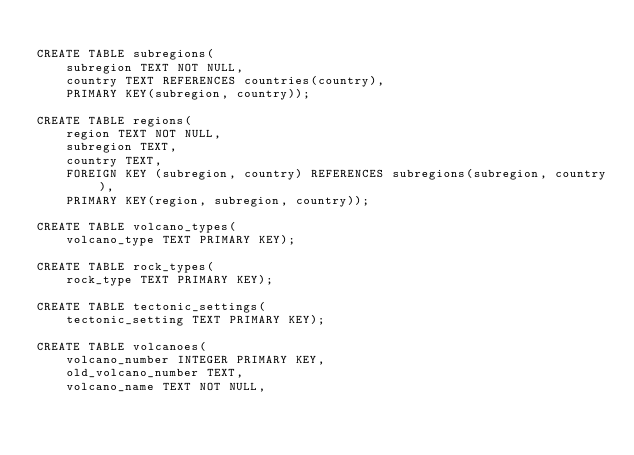Convert code to text. <code><loc_0><loc_0><loc_500><loc_500><_SQL_>
CREATE TABLE subregions(
	subregion TEXT NOT NULL,
	country TEXT REFERENCES countries(country),
	PRIMARY KEY(subregion, country));
	
CREATE TABLE regions(
	region TEXT NOT NULL,
	subregion TEXT,
	country TEXT,
	FOREIGN KEY (subregion, country) REFERENCES subregions(subregion, country),
	PRIMARY KEY(region, subregion, country));
	
CREATE TABLE volcano_types(
	volcano_type TEXT PRIMARY KEY);
	
CREATE TABLE rock_types(
	rock_type TEXT PRIMARY KEY);

CREATE TABLE tectonic_settings(
	tectonic_setting TEXT PRIMARY KEY);

CREATE TABLE volcanoes(
	volcano_number INTEGER PRIMARY KEY,
	old_volcano_number TEXT,
	volcano_name TEXT NOT NULL,</code> 